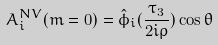<formula> <loc_0><loc_0><loc_500><loc_500>A _ { i } ^ { N V } ( m = 0 ) = \hat { \phi } _ { i } ( \frac { \tau _ { 3 } } { 2 i \rho } ) \cos \theta</formula> 